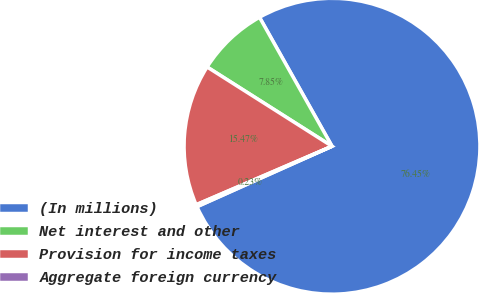<chart> <loc_0><loc_0><loc_500><loc_500><pie_chart><fcel>(In millions)<fcel>Net interest and other<fcel>Provision for income taxes<fcel>Aggregate foreign currency<nl><fcel>76.45%<fcel>7.85%<fcel>15.47%<fcel>0.23%<nl></chart> 